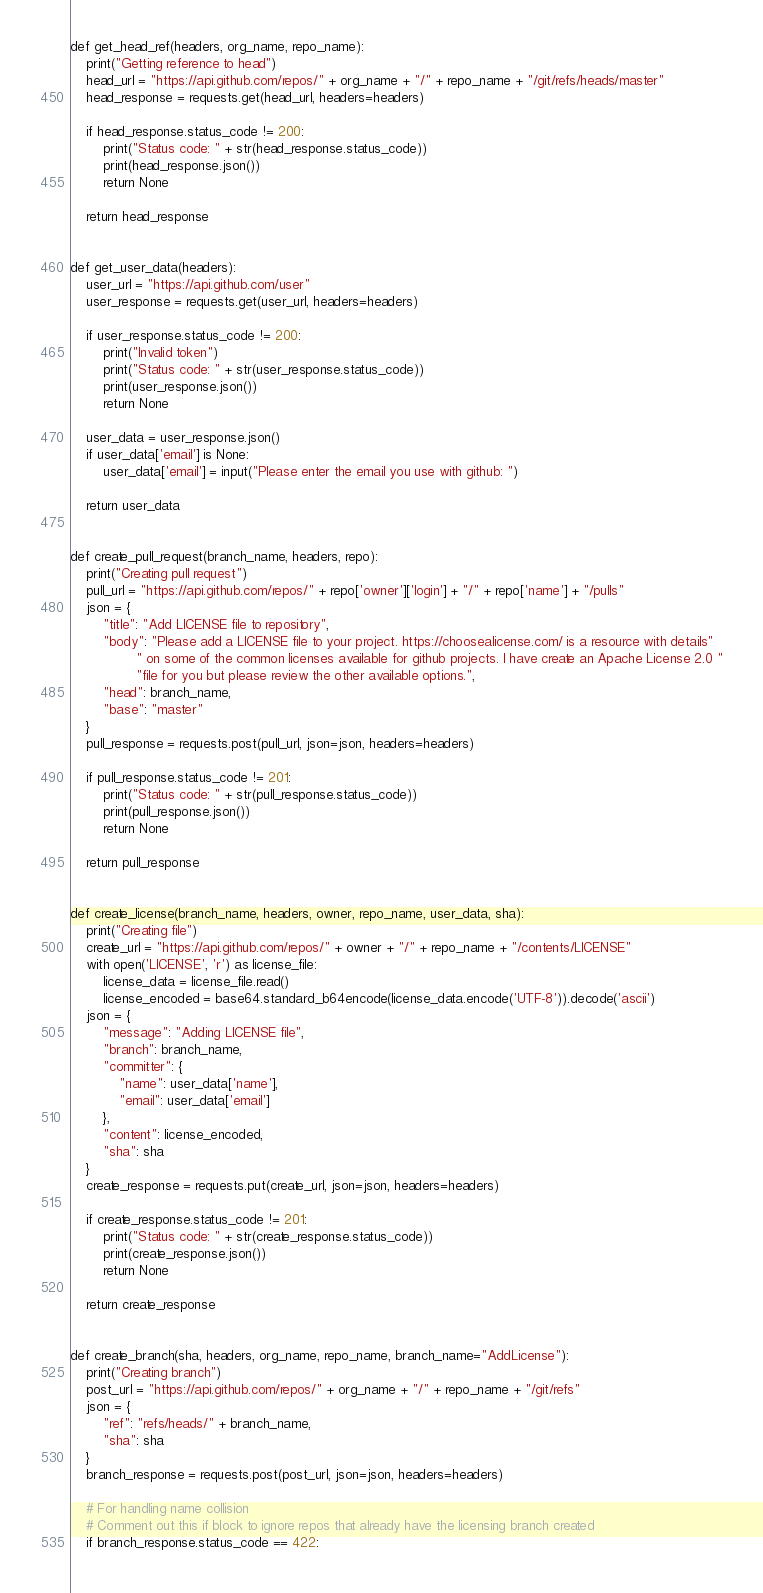Convert code to text. <code><loc_0><loc_0><loc_500><loc_500><_Python_>def get_head_ref(headers, org_name, repo_name):
    print("Getting reference to head")
    head_url = "https://api.github.com/repos/" + org_name + "/" + repo_name + "/git/refs/heads/master"
    head_response = requests.get(head_url, headers=headers)

    if head_response.status_code != 200:
        print("Status code: " + str(head_response.status_code))
        print(head_response.json())
        return None

    return head_response


def get_user_data(headers):
    user_url = "https://api.github.com/user"
    user_response = requests.get(user_url, headers=headers)

    if user_response.status_code != 200:
        print("Invalid token")
        print("Status code: " + str(user_response.status_code))
        print(user_response.json())
        return None

    user_data = user_response.json()
    if user_data['email'] is None:
        user_data['email'] = input("Please enter the email you use with github: ")

    return user_data


def create_pull_request(branch_name, headers, repo):
    print("Creating pull request")
    pull_url = "https://api.github.com/repos/" + repo['owner']['login'] + "/" + repo['name'] + "/pulls"
    json = {
        "title": "Add LICENSE file to repository",
        "body": "Please add a LICENSE file to your project. https://choosealicense.com/ is a resource with details"
                " on some of the common licenses available for github projects. I have create an Apache License 2.0 "
                "file for you but please review the other available options.",
        "head": branch_name,
        "base": "master"
    }
    pull_response = requests.post(pull_url, json=json, headers=headers)

    if pull_response.status_code != 201:
        print("Status code: " + str(pull_response.status_code))
        print(pull_response.json())
        return None

    return pull_response


def create_license(branch_name, headers, owner, repo_name, user_data, sha):
    print("Creating file")
    create_url = "https://api.github.com/repos/" + owner + "/" + repo_name + "/contents/LICENSE"
    with open('LICENSE', 'r') as license_file:
        license_data = license_file.read()
        license_encoded = base64.standard_b64encode(license_data.encode('UTF-8')).decode('ascii')
    json = {
        "message": "Adding LICENSE file",
        "branch": branch_name,
        "committer": {
            "name": user_data['name'],
            "email": user_data['email']
        },
        "content": license_encoded,
        "sha": sha
    }
    create_response = requests.put(create_url, json=json, headers=headers)

    if create_response.status_code != 201:
        print("Status code: " + str(create_response.status_code))
        print(create_response.json())
        return None

    return create_response


def create_branch(sha, headers, org_name, repo_name, branch_name="AddLicense"):
    print("Creating branch")
    post_url = "https://api.github.com/repos/" + org_name + "/" + repo_name + "/git/refs"
    json = {
        "ref": "refs/heads/" + branch_name,
        "sha": sha
    }
    branch_response = requests.post(post_url, json=json, headers=headers)

    # For handling name collision
    # Comment out this if block to ignore repos that already have the licensing branch created
    if branch_response.status_code == 422:</code> 